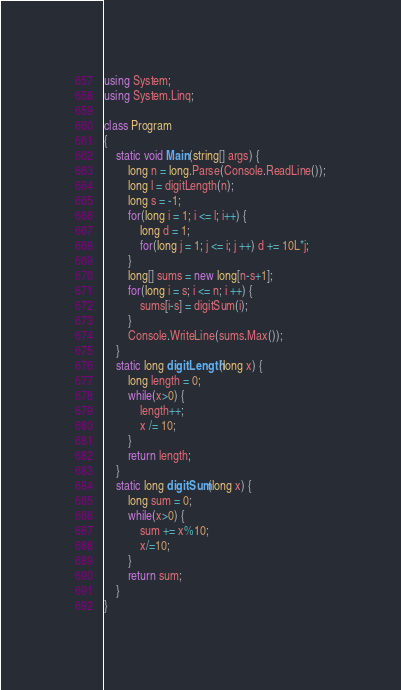<code> <loc_0><loc_0><loc_500><loc_500><_C#_>using System;
using System.Linq;

class Program
{
    static void Main(string[] args) {
        long n = long.Parse(Console.ReadLine());
        long l = digitLength(n);
        long s = -1;
        for(long i = 1; i <= l; i++) {
            long d = 1;
            for(long j = 1; j <= i; j ++) d += 10L*j;
        }
        long[] sums = new long[n-s+1];
        for(long i = s; i <= n; i ++) {
            sums[i-s] = digitSum(i);
        }
        Console.WriteLine(sums.Max());
    }
    static long digitLength(long x) {
        long length = 0;
        while(x>0) {
            length++;
            x /= 10;
        }
        return length;
    }
    static long digitSum(long x) {
        long sum = 0;
        while(x>0) {
            sum += x%10;
            x/=10;
        }
        return sum;
    }
}</code> 